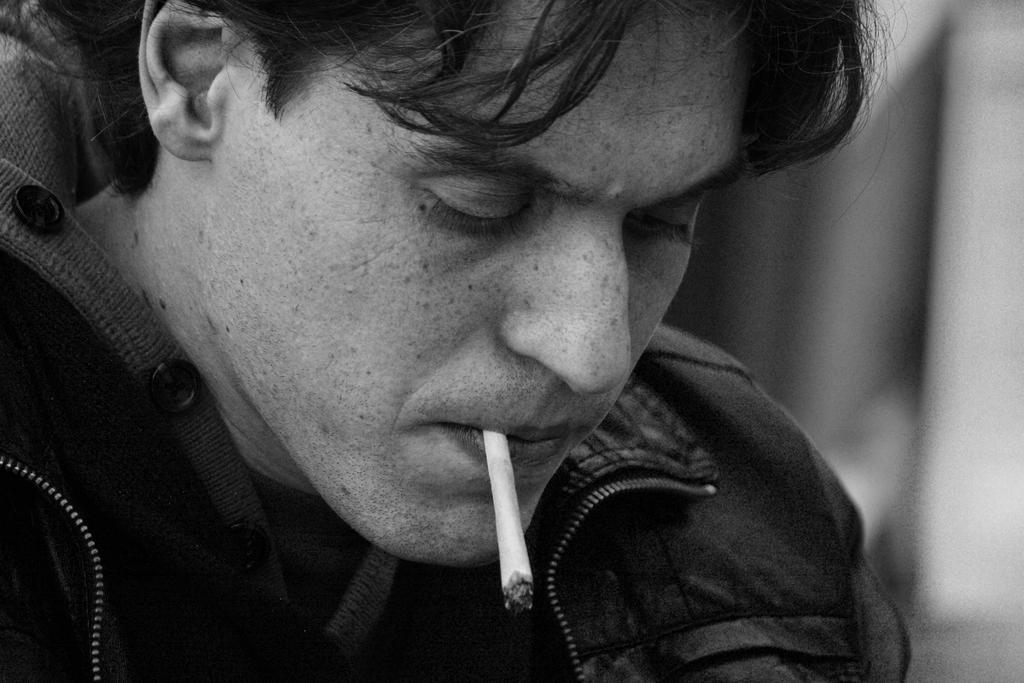Who is the main subject in the image? There is a man in the image. What is the man wearing? The man is wearing a jacket. What is the man holding in his mouth? The man is holding a cigarette in his mouth. What songs is the man singing in the image? There is no indication in the image that the man is singing any songs. 